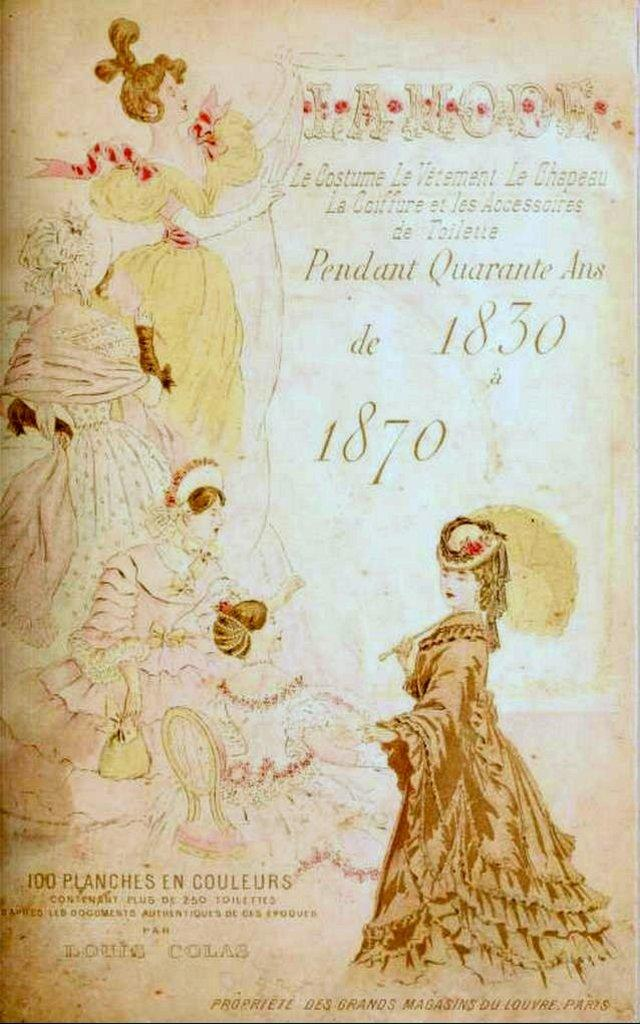What is the main subject of the poster in the image? The poster contains images of women. Are there any other elements on the poster besides the images? Yes, there is text on the poster. What advice does the uncle give during the discussion in the image? There is no uncle or discussion present in the image; it only features a poster with images of women and text. 